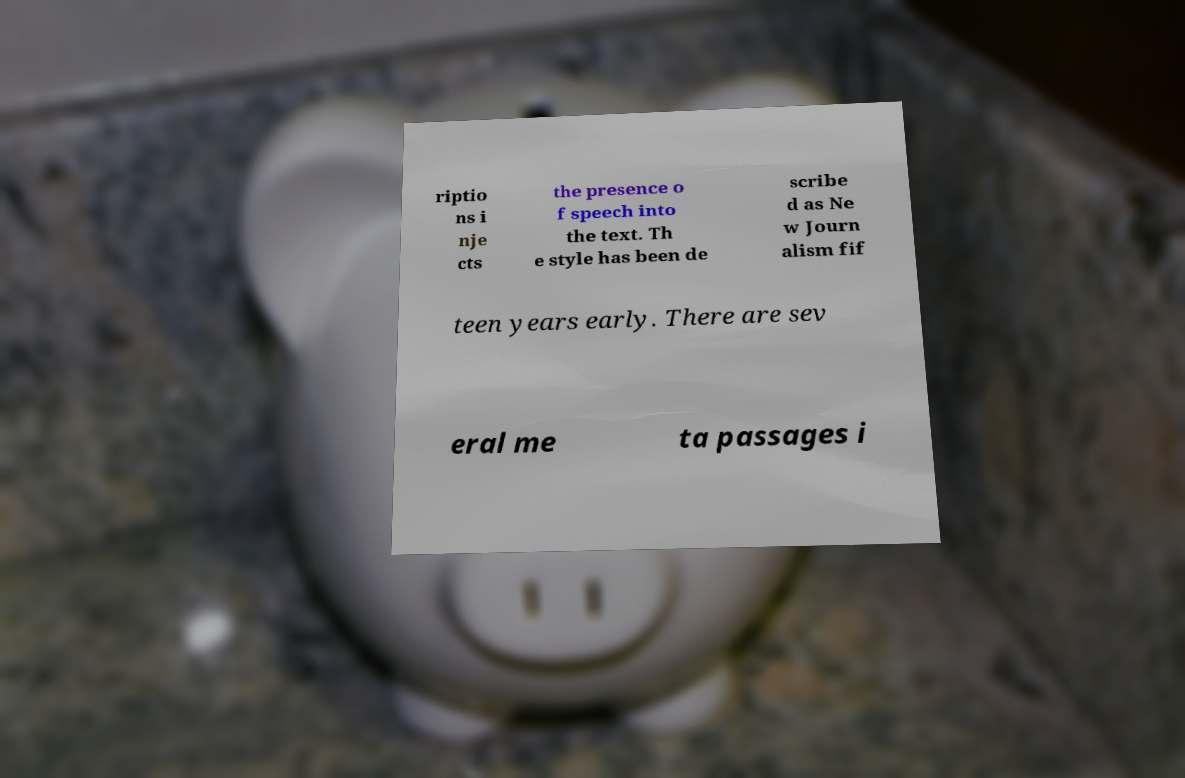What messages or text are displayed in this image? I need them in a readable, typed format. riptio ns i nje cts the presence o f speech into the text. Th e style has been de scribe d as Ne w Journ alism fif teen years early. There are sev eral me ta passages i 